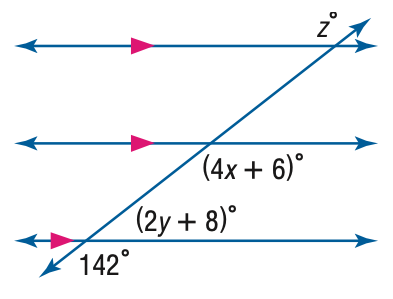Answer the mathemtical geometry problem and directly provide the correct option letter.
Question: Find x in the figure.
Choices: A: 15 B: 34 C: 39.5 D: 142 B 